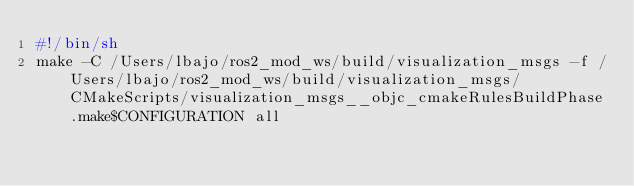<code> <loc_0><loc_0><loc_500><loc_500><_Bash_>#!/bin/sh
make -C /Users/lbajo/ros2_mod_ws/build/visualization_msgs -f /Users/lbajo/ros2_mod_ws/build/visualization_msgs/CMakeScripts/visualization_msgs__objc_cmakeRulesBuildPhase.make$CONFIGURATION all
</code> 